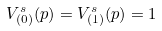Convert formula to latex. <formula><loc_0><loc_0><loc_500><loc_500>V ^ { s } _ { ( 0 ) } ( p ) = V ^ { s } _ { ( 1 ) } ( p ) = 1</formula> 